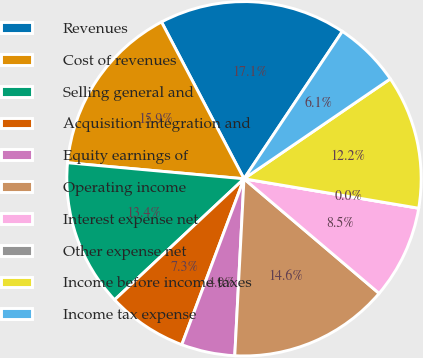Convert chart. <chart><loc_0><loc_0><loc_500><loc_500><pie_chart><fcel>Revenues<fcel>Cost of revenues<fcel>Selling general and<fcel>Acquisition integration and<fcel>Equity earnings of<fcel>Operating income<fcel>Interest expense net<fcel>Other expense net<fcel>Income before income taxes<fcel>Income tax expense<nl><fcel>17.07%<fcel>15.85%<fcel>13.41%<fcel>7.32%<fcel>4.88%<fcel>14.63%<fcel>8.54%<fcel>0.0%<fcel>12.19%<fcel>6.1%<nl></chart> 